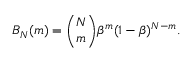Convert formula to latex. <formula><loc_0><loc_0><loc_500><loc_500>B _ { N } ( m ) = \binom { N } { m } \beta ^ { m } ( 1 - \beta ) ^ { N - m } .</formula> 